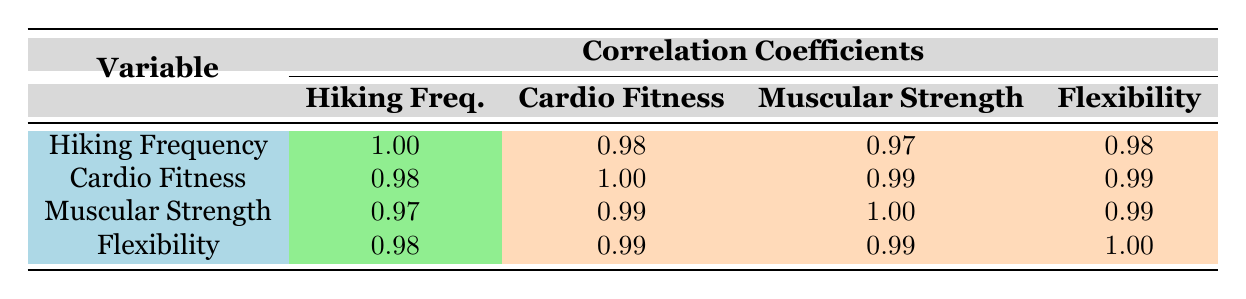What is the correlation coefficient between hiking frequency and cardio fitness? From the table, the correlation coefficient listed under the hiking frequency and cardio fitness columns is 0.98.
Answer: 0.98 How does hiking frequency correlate with muscular strength? The correlation coefficient for hiking frequency and muscular strength is found in the appropriate column of the table, which is 0.97.
Answer: 0.97 Is the correlation between cardio fitness and flexibility greater than 0.98? The correlation coefficient between cardio fitness and flexibility is given as 0.99, which is indeed greater than 0.98.
Answer: Yes What is the average correlation coefficient for all the fitness levels with hiking frequency? The correlation coefficients are 0.98 (cardio fitness), 0.97 (muscular strength), and 0.98 (flexibility). The average is (0.98 + 0.97 + 0.98) / 3 = 0.98.
Answer: 0.98 Does muscular strength have a correlation coefficient with hiking frequency lower than 0.95? Looking at the table, the correlation coefficient between hiking frequency and muscular strength is 0.97, which is not lower than 0.95.
Answer: No What is the correlation coefficient between flexibility and muscular strength? Referring to the table, the correlation coefficient between flexibility and muscular strength is listed as 0.99.
Answer: 0.99 If a new participant hikes 12 times a month, can we expect their cardio fitness level to be above 85 based on these correlations? Based on the high correlation (0.98) between hiking frequency and cardio fitness, if a participant hikes frequently, we would indeed expect their cardio fitness level to be high; therefore, it can be reasonably predicted to be above 85 since 12 hikes is more than most frequencies recorded.
Answer: Yes What correlation is observed between flexibility and hiking frequency? The table indicates the correlation coefficient between flexibility and hiking frequency is 0.98.
Answer: 0.98 Is there a perfect correlation between cardio fitness and muscular strength? The correlation coefficient between cardio fitness and muscular strength is 0.99, which is very close to 1 but not perfectly correlating; thus, it is not a perfect correlation.
Answer: No 